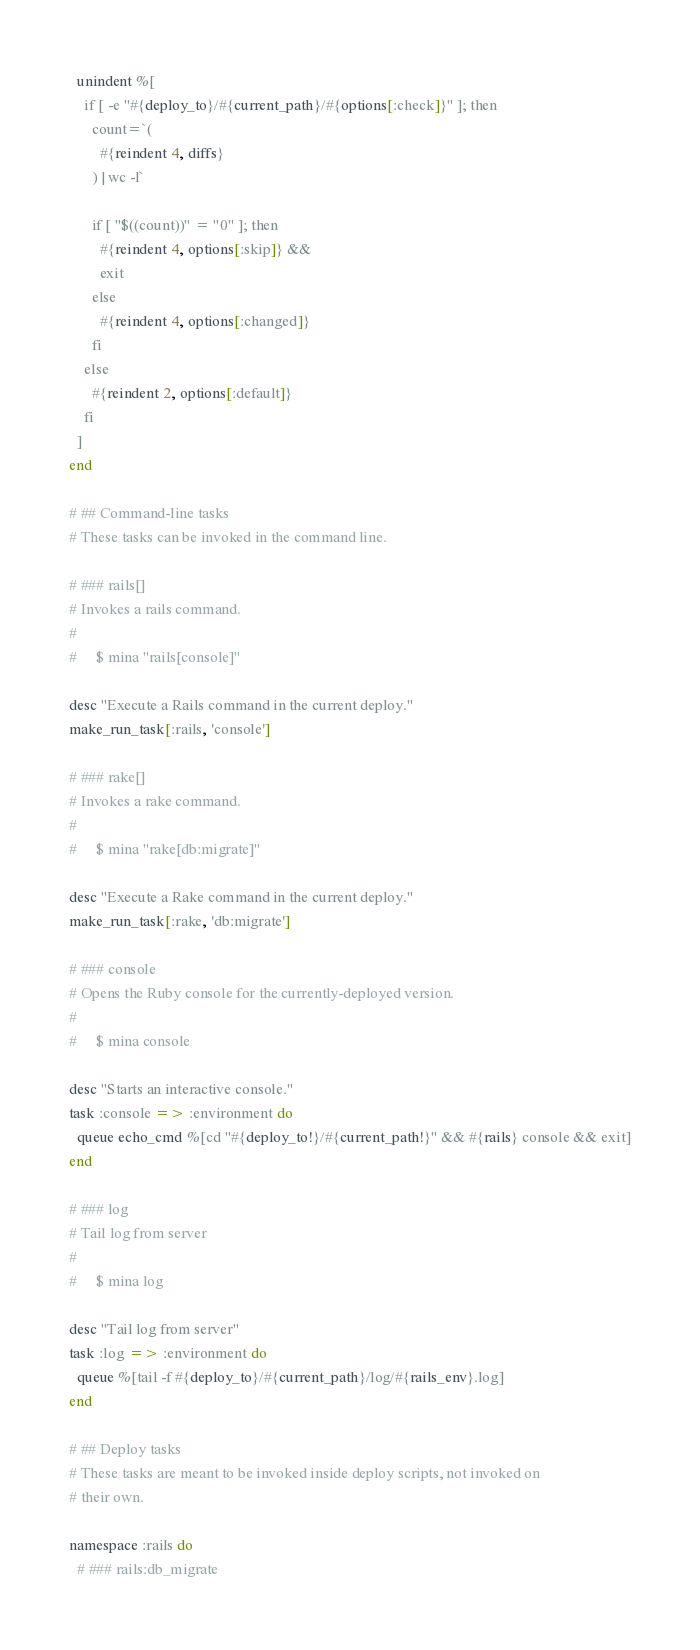<code> <loc_0><loc_0><loc_500><loc_500><_Ruby_>  unindent %[
    if [ -e "#{deploy_to}/#{current_path}/#{options[:check]}" ]; then
      count=`(
        #{reindent 4, diffs}
      ) | wc -l`

      if [ "$((count))" = "0" ]; then
        #{reindent 4, options[:skip]} &&
        exit
      else
        #{reindent 4, options[:changed]}
      fi
    else
      #{reindent 2, options[:default]}
    fi
  ]
end

# ## Command-line tasks
# These tasks can be invoked in the command line.

# ### rails[]
# Invokes a rails command.
#
#     $ mina "rails[console]"

desc "Execute a Rails command in the current deploy."
make_run_task[:rails, 'console']

# ### rake[]
# Invokes a rake command.
#
#     $ mina "rake[db:migrate]"

desc "Execute a Rake command in the current deploy."
make_run_task[:rake, 'db:migrate']

# ### console
# Opens the Ruby console for the currently-deployed version.
#
#     $ mina console

desc "Starts an interactive console."
task :console => :environment do
  queue echo_cmd %[cd "#{deploy_to!}/#{current_path!}" && #{rails} console && exit]
end

# ### log
# Tail log from server
#
#     $ mina log

desc "Tail log from server"
task :log => :environment do
  queue %[tail -f #{deploy_to}/#{current_path}/log/#{rails_env}.log]
end

# ## Deploy tasks
# These tasks are meant to be invoked inside deploy scripts, not invoked on
# their own.

namespace :rails do
  # ### rails:db_migrate</code> 